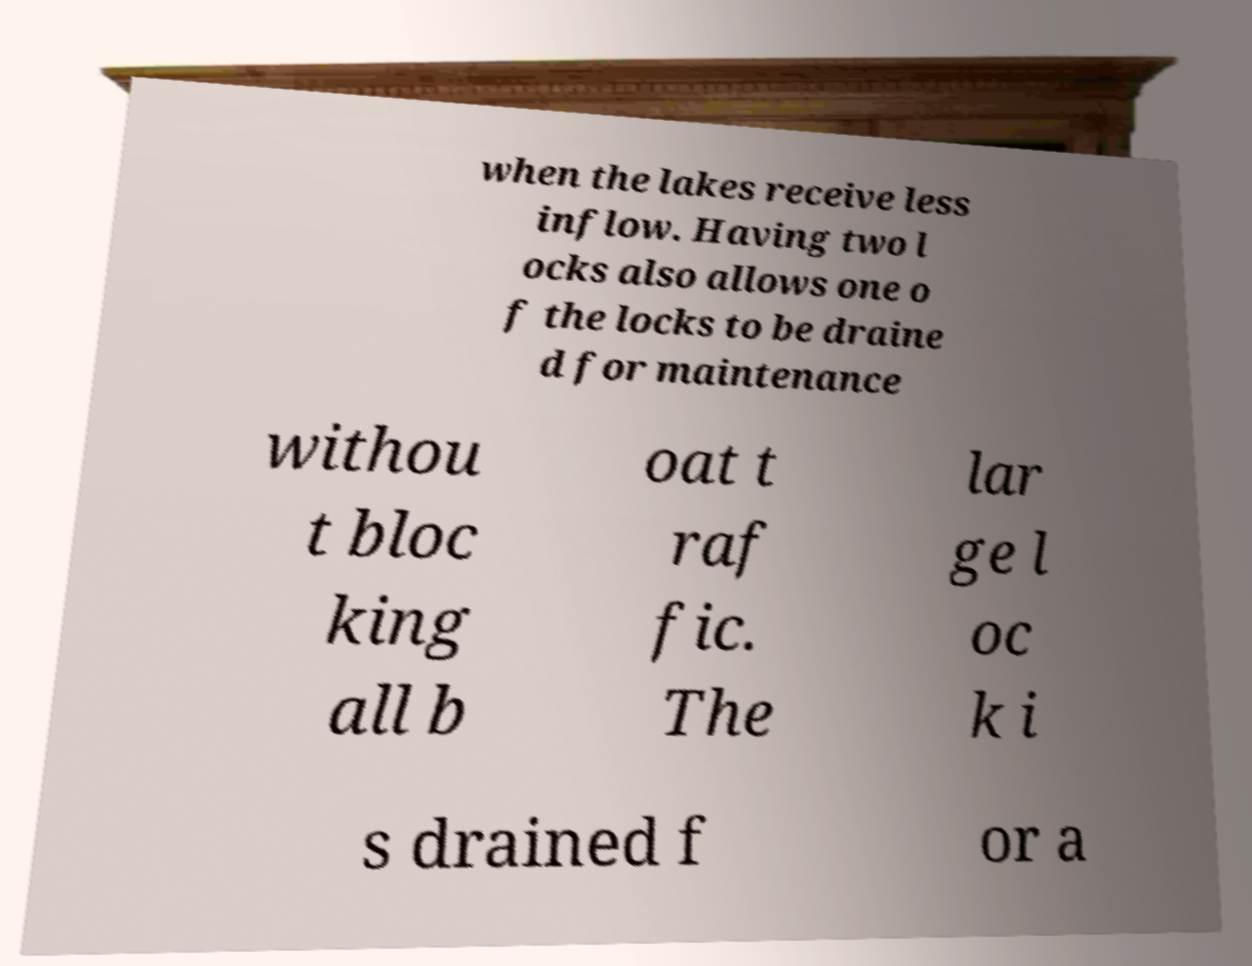Could you extract and type out the text from this image? when the lakes receive less inflow. Having two l ocks also allows one o f the locks to be draine d for maintenance withou t bloc king all b oat t raf fic. The lar ge l oc k i s drained f or a 